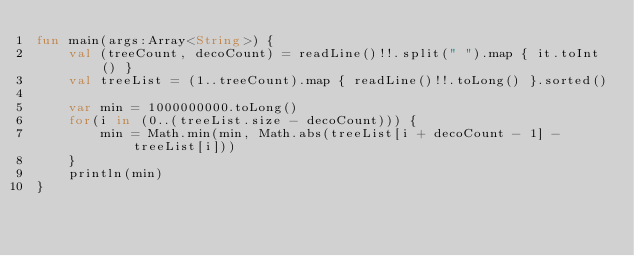Convert code to text. <code><loc_0><loc_0><loc_500><loc_500><_Kotlin_>fun main(args:Array<String>) {
    val (treeCount, decoCount) = readLine()!!.split(" ").map { it.toInt() }
    val treeList = (1..treeCount).map { readLine()!!.toLong() }.sorted()

    var min = 1000000000.toLong()
    for(i in (0..(treeList.size - decoCount))) {
        min = Math.min(min, Math.abs(treeList[i + decoCount - 1] - treeList[i]))
    }
    println(min)
}
</code> 